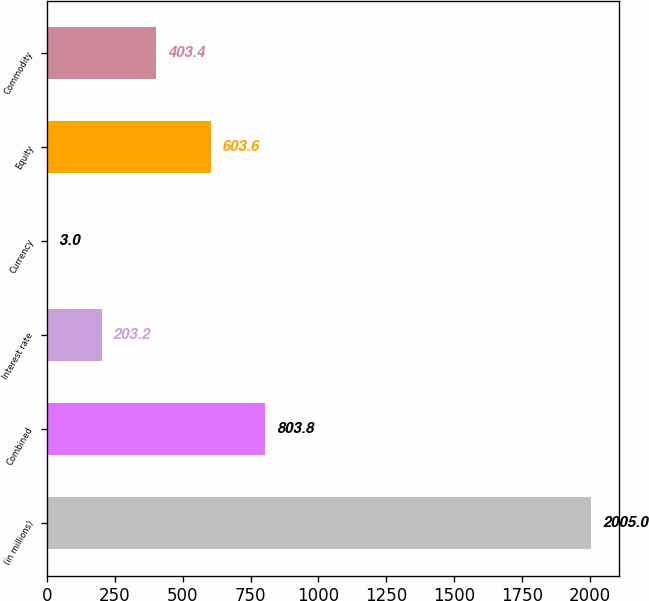Convert chart to OTSL. <chart><loc_0><loc_0><loc_500><loc_500><bar_chart><fcel>(in millions)<fcel>Combined<fcel>Interest rate<fcel>Currency<fcel>Equity<fcel>Commodity<nl><fcel>2005<fcel>803.8<fcel>203.2<fcel>3<fcel>603.6<fcel>403.4<nl></chart> 